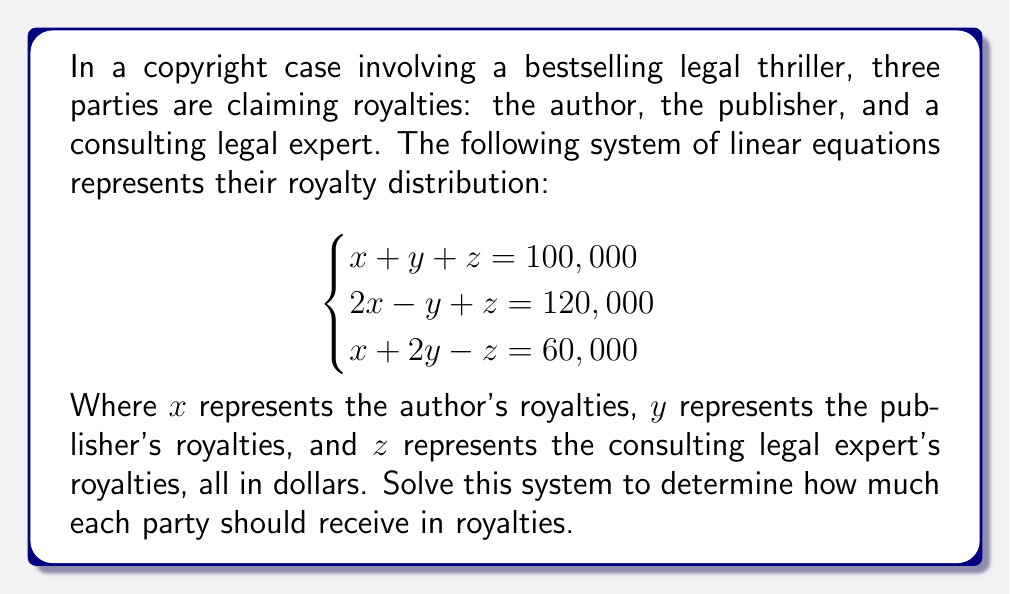Teach me how to tackle this problem. To solve this system of linear equations, we'll use the Gaussian elimination method:

1) First, write the augmented matrix:

$$\begin{bmatrix}
1 & 1 & 1 & 100,000 \\
2 & -1 & 1 & 120,000 \\
1 & 2 & -1 & 60,000
\end{bmatrix}$$

2) Multiply the first row by -2 and add it to the second row:

$$\begin{bmatrix}
1 & 1 & 1 & 100,000 \\
0 & -3 & -1 & -80,000 \\
1 & 2 & -1 & 60,000
\end{bmatrix}$$

3) Subtract the first row from the third row:

$$\begin{bmatrix}
1 & 1 & 1 & 100,000 \\
0 & -3 & -1 & -80,000 \\
0 & 1 & -2 & -40,000
\end{bmatrix}$$

4) Multiply the second row by -1/3:

$$\begin{bmatrix}
1 & 1 & 1 & 100,000 \\
0 & 1 & 1/3 & 26,667 \\
0 & 1 & -2 & -40,000
\end{bmatrix}$$

5) Subtract the second row from the third row:

$$\begin{bmatrix}
1 & 1 & 1 & 100,000 \\
0 & 1 & 1/3 & 26,667 \\
0 & 0 & -7/3 & -66,667
\end{bmatrix}$$

6) Multiply the third row by -3/7:

$$\begin{bmatrix}
1 & 1 & 1 & 100,000 \\
0 & 1 & 1/3 & 26,667 \\
0 & 0 & 1 & 28,571
\end{bmatrix}$$

7) Now we can solve by back-substitution:

$z = 28,571$

$y + 1/3(28,571) = 26,667$
$y = 26,667 - 9,524 = 17,143$

$x + 17,143 + 28,571 = 100,000$
$x = 100,000 - 17,143 - 28,571 = 54,286$

Therefore, the author ($x$) should receive $54,286, the publisher ($y$) should receive $17,143, and the consulting legal expert ($z$) should receive $28,571 in royalties.
Answer: Author: $54,286; Publisher: $17,143; Legal Expert: $28,571 